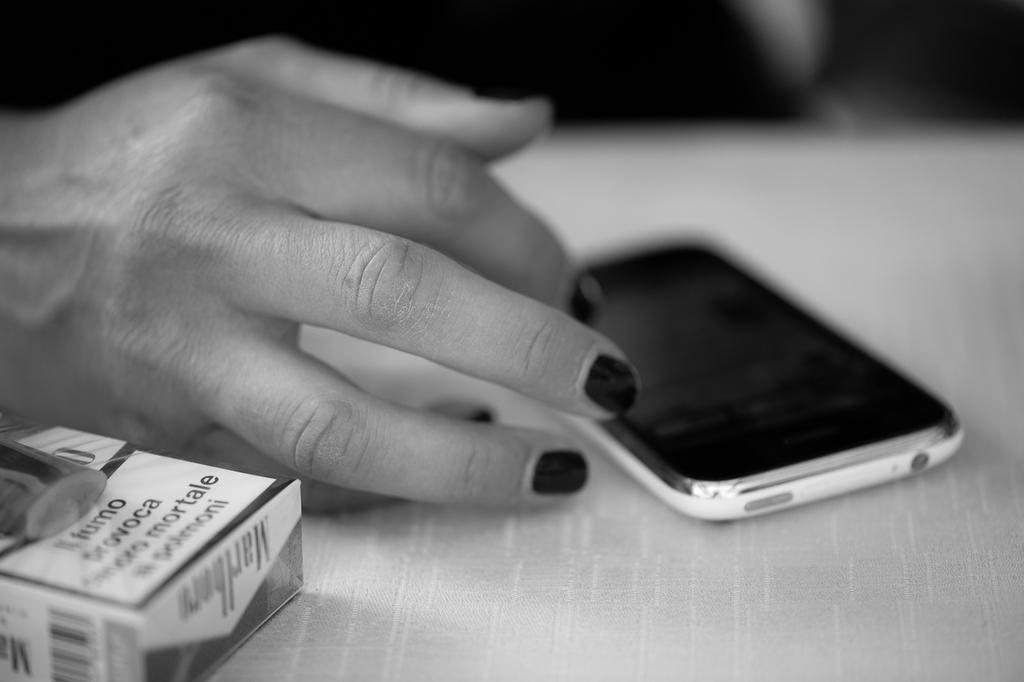<image>
Relay a brief, clear account of the picture shown. A woman uses her phone next to a box of Marlboro cigarettes. 